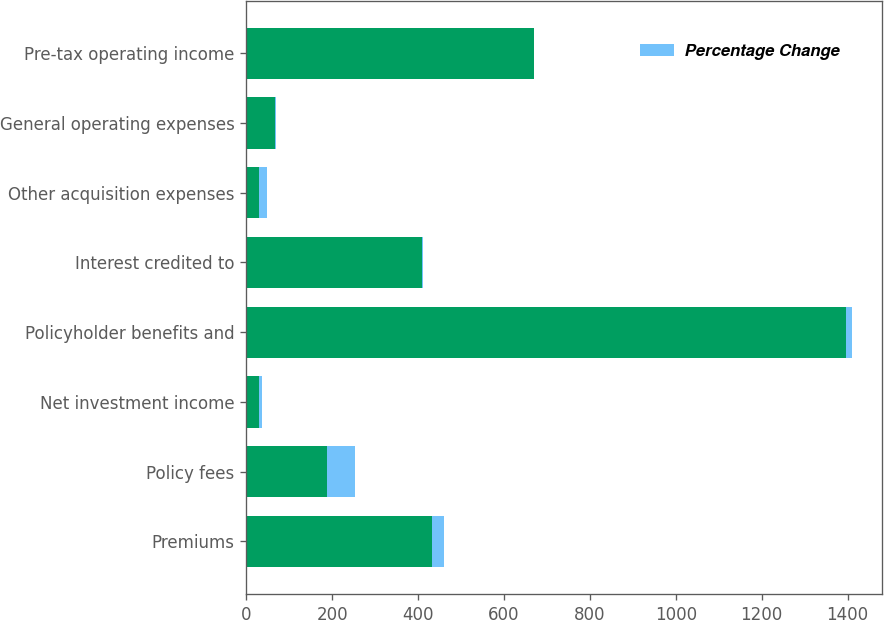Convert chart. <chart><loc_0><loc_0><loc_500><loc_500><stacked_bar_chart><ecel><fcel>Premiums<fcel>Policy fees<fcel>Net investment income<fcel>Policyholder benefits and<fcel>Interest credited to<fcel>Other acquisition expenses<fcel>General operating expenses<fcel>Pre-tax operating income<nl><fcel>nan<fcel>432<fcel>187<fcel>30<fcel>1396<fcel>410<fcel>30<fcel>66<fcel>670<nl><fcel>Percentage Change<fcel>29<fcel>65<fcel>6<fcel>14<fcel>1<fcel>17<fcel>3<fcel>1<nl></chart> 